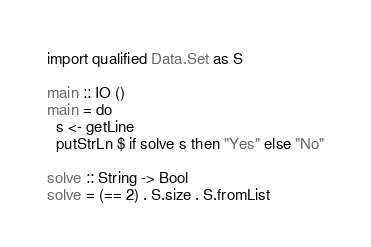<code> <loc_0><loc_0><loc_500><loc_500><_Haskell_>import qualified Data.Set as S

main :: IO ()
main = do
  s <- getLine
  putStrLn $ if solve s then "Yes" else "No"

solve :: String -> Bool
solve = (== 2) . S.size . S.fromList</code> 